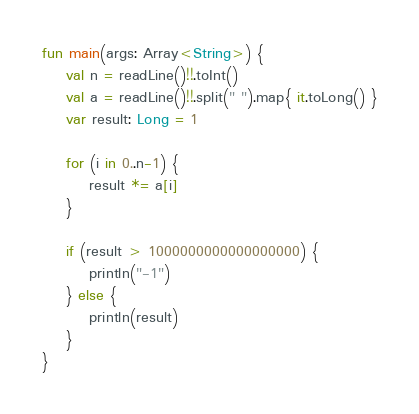<code> <loc_0><loc_0><loc_500><loc_500><_Kotlin_>fun main(args: Array<String>) {
	val n = readLine()!!.toInt()
  	val a = readLine()!!.split(" ").map{ it.toLong() }
  	var result: Long = 1
  
  	for (i in 0..n-1) {
    	result *= a[i]	
    }
  
  	if (result > 1000000000000000000) {
  		println("-1")
  	} else {
    	println(result)  
    }
}</code> 